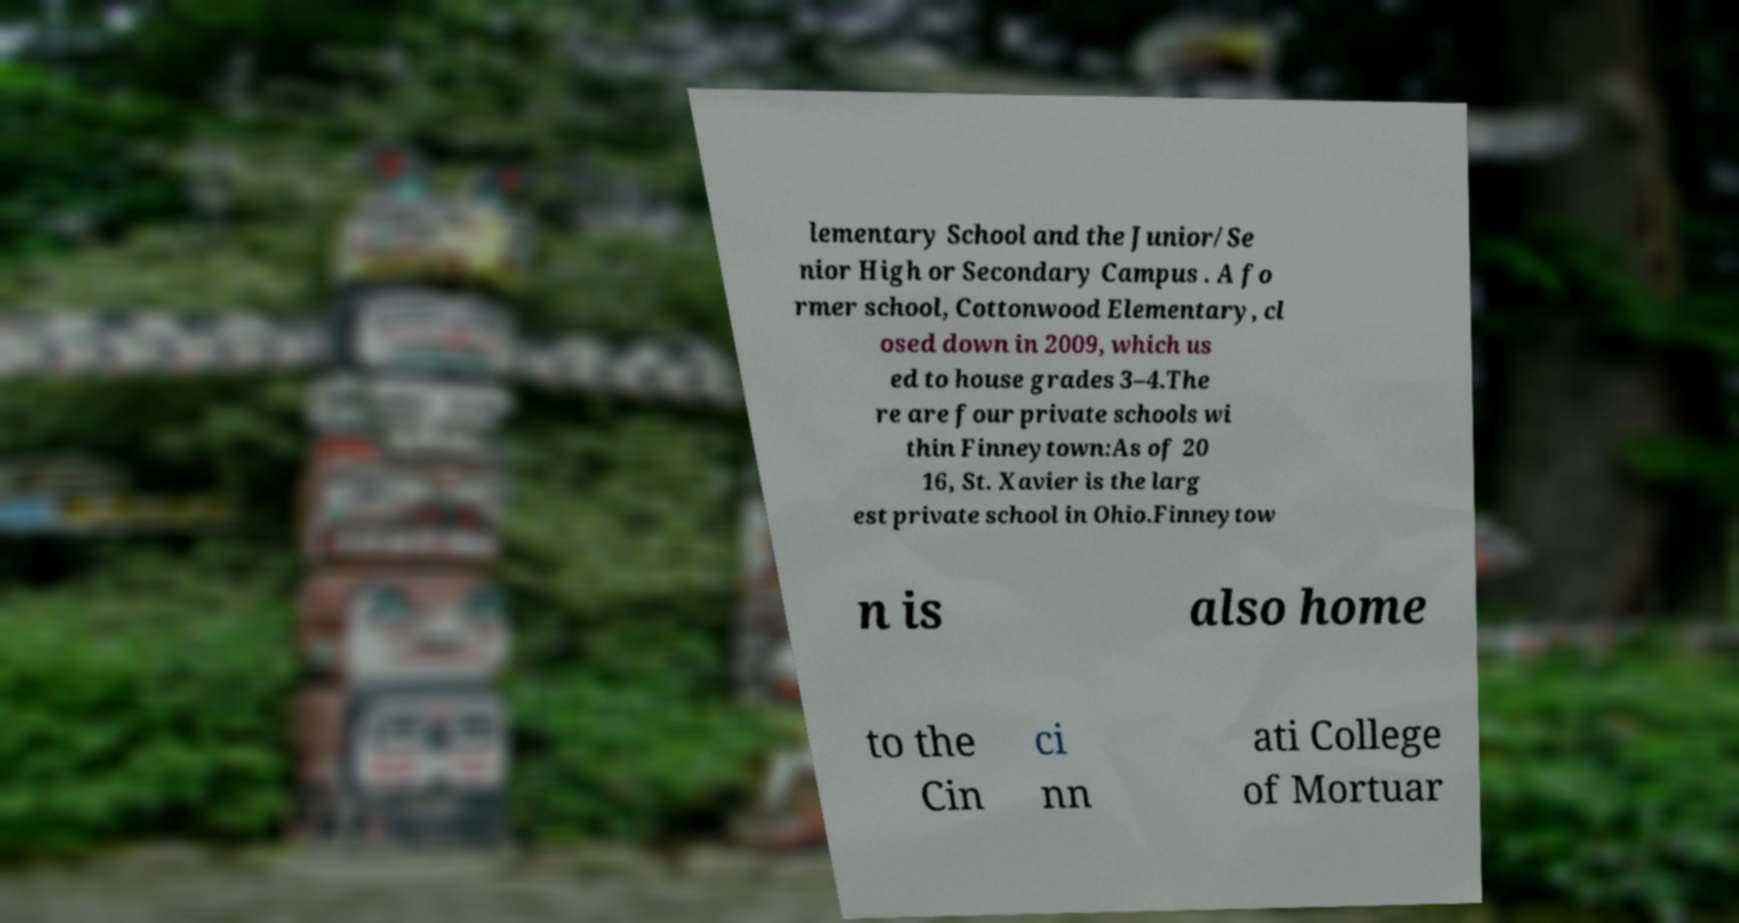What messages or text are displayed in this image? I need them in a readable, typed format. lementary School and the Junior/Se nior High or Secondary Campus . A fo rmer school, Cottonwood Elementary, cl osed down in 2009, which us ed to house grades 3–4.The re are four private schools wi thin Finneytown:As of 20 16, St. Xavier is the larg est private school in Ohio.Finneytow n is also home to the Cin ci nn ati College of Mortuar 